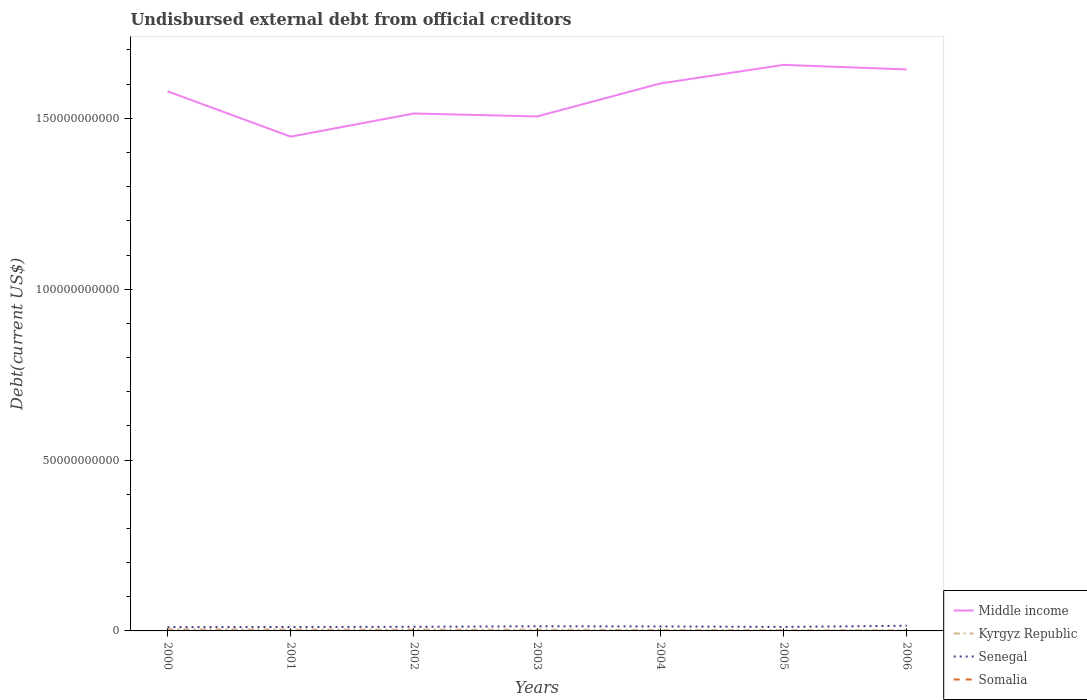Does the line corresponding to Middle income intersect with the line corresponding to Somalia?
Your answer should be very brief. No. Is the number of lines equal to the number of legend labels?
Offer a terse response. Yes. Across all years, what is the maximum total debt in Kyrgyz Republic?
Provide a succinct answer. 1.80e+08. In which year was the total debt in Kyrgyz Republic maximum?
Your answer should be compact. 2006. What is the total total debt in Middle income in the graph?
Your answer should be compact. -1.29e+1. What is the difference between the highest and the second highest total debt in Somalia?
Offer a terse response. 7.91e+06. What is the difference between the highest and the lowest total debt in Kyrgyz Republic?
Ensure brevity in your answer.  4. How many years are there in the graph?
Your answer should be compact. 7. Does the graph contain any zero values?
Keep it short and to the point. No. Does the graph contain grids?
Provide a short and direct response. No. What is the title of the graph?
Give a very brief answer. Undisbursed external debt from official creditors. What is the label or title of the Y-axis?
Give a very brief answer. Debt(current US$). What is the Debt(current US$) of Middle income in 2000?
Your answer should be very brief. 1.58e+11. What is the Debt(current US$) of Kyrgyz Republic in 2000?
Keep it short and to the point. 4.70e+08. What is the Debt(current US$) in Senegal in 2000?
Your answer should be very brief. 1.11e+09. What is the Debt(current US$) of Somalia in 2000?
Offer a terse response. 1.23e+07. What is the Debt(current US$) of Middle income in 2001?
Offer a terse response. 1.45e+11. What is the Debt(current US$) in Kyrgyz Republic in 2001?
Make the answer very short. 4.04e+08. What is the Debt(current US$) of Senegal in 2001?
Ensure brevity in your answer.  1.15e+09. What is the Debt(current US$) of Somalia in 2001?
Offer a very short reply. 1.23e+07. What is the Debt(current US$) of Middle income in 2002?
Make the answer very short. 1.51e+11. What is the Debt(current US$) of Kyrgyz Republic in 2002?
Give a very brief answer. 3.86e+08. What is the Debt(current US$) in Senegal in 2002?
Offer a terse response. 1.21e+09. What is the Debt(current US$) of Somalia in 2002?
Your response must be concise. 1.24e+07. What is the Debt(current US$) in Middle income in 2003?
Give a very brief answer. 1.51e+11. What is the Debt(current US$) in Kyrgyz Republic in 2003?
Make the answer very short. 3.73e+08. What is the Debt(current US$) of Senegal in 2003?
Your answer should be compact. 1.36e+09. What is the Debt(current US$) of Somalia in 2003?
Provide a succinct answer. 4.52e+06. What is the Debt(current US$) of Middle income in 2004?
Offer a very short reply. 1.60e+11. What is the Debt(current US$) in Kyrgyz Republic in 2004?
Offer a terse response. 2.79e+08. What is the Debt(current US$) in Senegal in 2004?
Give a very brief answer. 1.31e+09. What is the Debt(current US$) in Somalia in 2004?
Keep it short and to the point. 4.54e+06. What is the Debt(current US$) of Middle income in 2005?
Ensure brevity in your answer.  1.66e+11. What is the Debt(current US$) of Kyrgyz Republic in 2005?
Keep it short and to the point. 2.44e+08. What is the Debt(current US$) in Senegal in 2005?
Provide a short and direct response. 1.17e+09. What is the Debt(current US$) in Somalia in 2005?
Your answer should be very brief. 4.54e+06. What is the Debt(current US$) of Middle income in 2006?
Provide a short and direct response. 1.64e+11. What is the Debt(current US$) in Kyrgyz Republic in 2006?
Ensure brevity in your answer.  1.80e+08. What is the Debt(current US$) in Senegal in 2006?
Make the answer very short. 1.51e+09. What is the Debt(current US$) of Somalia in 2006?
Give a very brief answer. 4.60e+06. Across all years, what is the maximum Debt(current US$) of Middle income?
Provide a short and direct response. 1.66e+11. Across all years, what is the maximum Debt(current US$) in Kyrgyz Republic?
Your answer should be very brief. 4.70e+08. Across all years, what is the maximum Debt(current US$) in Senegal?
Ensure brevity in your answer.  1.51e+09. Across all years, what is the maximum Debt(current US$) of Somalia?
Provide a short and direct response. 1.24e+07. Across all years, what is the minimum Debt(current US$) of Middle income?
Make the answer very short. 1.45e+11. Across all years, what is the minimum Debt(current US$) of Kyrgyz Republic?
Your response must be concise. 1.80e+08. Across all years, what is the minimum Debt(current US$) of Senegal?
Provide a short and direct response. 1.11e+09. Across all years, what is the minimum Debt(current US$) in Somalia?
Your answer should be very brief. 4.52e+06. What is the total Debt(current US$) in Middle income in the graph?
Provide a short and direct response. 1.09e+12. What is the total Debt(current US$) of Kyrgyz Republic in the graph?
Give a very brief answer. 2.34e+09. What is the total Debt(current US$) in Senegal in the graph?
Offer a very short reply. 8.82e+09. What is the total Debt(current US$) in Somalia in the graph?
Offer a terse response. 5.52e+07. What is the difference between the Debt(current US$) of Middle income in 2000 and that in 2001?
Provide a succinct answer. 1.33e+1. What is the difference between the Debt(current US$) in Kyrgyz Republic in 2000 and that in 2001?
Offer a very short reply. 6.66e+07. What is the difference between the Debt(current US$) of Senegal in 2000 and that in 2001?
Ensure brevity in your answer.  -4.41e+07. What is the difference between the Debt(current US$) of Somalia in 2000 and that in 2001?
Your answer should be compact. 4.60e+04. What is the difference between the Debt(current US$) of Middle income in 2000 and that in 2002?
Your answer should be compact. 6.49e+09. What is the difference between the Debt(current US$) of Kyrgyz Republic in 2000 and that in 2002?
Give a very brief answer. 8.46e+07. What is the difference between the Debt(current US$) of Senegal in 2000 and that in 2002?
Keep it short and to the point. -1.01e+08. What is the difference between the Debt(current US$) of Somalia in 2000 and that in 2002?
Provide a short and direct response. -9.10e+04. What is the difference between the Debt(current US$) of Middle income in 2000 and that in 2003?
Give a very brief answer. 7.36e+09. What is the difference between the Debt(current US$) of Kyrgyz Republic in 2000 and that in 2003?
Provide a short and direct response. 9.78e+07. What is the difference between the Debt(current US$) in Senegal in 2000 and that in 2003?
Give a very brief answer. -2.56e+08. What is the difference between the Debt(current US$) in Somalia in 2000 and that in 2003?
Your answer should be very brief. 7.82e+06. What is the difference between the Debt(current US$) in Middle income in 2000 and that in 2004?
Keep it short and to the point. -2.29e+09. What is the difference between the Debt(current US$) in Kyrgyz Republic in 2000 and that in 2004?
Offer a terse response. 1.91e+08. What is the difference between the Debt(current US$) in Senegal in 2000 and that in 2004?
Offer a very short reply. -2.04e+08. What is the difference between the Debt(current US$) of Somalia in 2000 and that in 2004?
Offer a terse response. 7.79e+06. What is the difference between the Debt(current US$) of Middle income in 2000 and that in 2005?
Provide a succinct answer. -7.73e+09. What is the difference between the Debt(current US$) of Kyrgyz Republic in 2000 and that in 2005?
Provide a succinct answer. 2.26e+08. What is the difference between the Debt(current US$) of Senegal in 2000 and that in 2005?
Keep it short and to the point. -6.37e+07. What is the difference between the Debt(current US$) of Somalia in 2000 and that in 2005?
Provide a short and direct response. 7.79e+06. What is the difference between the Debt(current US$) of Middle income in 2000 and that in 2006?
Provide a short and direct response. -6.40e+09. What is the difference between the Debt(current US$) in Kyrgyz Republic in 2000 and that in 2006?
Offer a very short reply. 2.90e+08. What is the difference between the Debt(current US$) of Senegal in 2000 and that in 2006?
Your answer should be very brief. -4.04e+08. What is the difference between the Debt(current US$) of Somalia in 2000 and that in 2006?
Offer a terse response. 7.73e+06. What is the difference between the Debt(current US$) of Middle income in 2001 and that in 2002?
Your answer should be compact. -6.78e+09. What is the difference between the Debt(current US$) in Kyrgyz Republic in 2001 and that in 2002?
Offer a terse response. 1.80e+07. What is the difference between the Debt(current US$) in Senegal in 2001 and that in 2002?
Keep it short and to the point. -5.67e+07. What is the difference between the Debt(current US$) in Somalia in 2001 and that in 2002?
Give a very brief answer. -1.37e+05. What is the difference between the Debt(current US$) of Middle income in 2001 and that in 2003?
Provide a succinct answer. -5.91e+09. What is the difference between the Debt(current US$) in Kyrgyz Republic in 2001 and that in 2003?
Provide a short and direct response. 3.12e+07. What is the difference between the Debt(current US$) of Senegal in 2001 and that in 2003?
Provide a succinct answer. -2.11e+08. What is the difference between the Debt(current US$) of Somalia in 2001 and that in 2003?
Give a very brief answer. 7.77e+06. What is the difference between the Debt(current US$) in Middle income in 2001 and that in 2004?
Provide a short and direct response. -1.56e+1. What is the difference between the Debt(current US$) of Kyrgyz Republic in 2001 and that in 2004?
Make the answer very short. 1.25e+08. What is the difference between the Debt(current US$) of Senegal in 2001 and that in 2004?
Your answer should be very brief. -1.60e+08. What is the difference between the Debt(current US$) in Somalia in 2001 and that in 2004?
Provide a short and direct response. 7.75e+06. What is the difference between the Debt(current US$) in Middle income in 2001 and that in 2005?
Your answer should be very brief. -2.10e+1. What is the difference between the Debt(current US$) in Kyrgyz Republic in 2001 and that in 2005?
Make the answer very short. 1.60e+08. What is the difference between the Debt(current US$) of Senegal in 2001 and that in 2005?
Give a very brief answer. -1.96e+07. What is the difference between the Debt(current US$) in Somalia in 2001 and that in 2005?
Make the answer very short. 7.74e+06. What is the difference between the Debt(current US$) in Middle income in 2001 and that in 2006?
Your response must be concise. -1.97e+1. What is the difference between the Debt(current US$) of Kyrgyz Republic in 2001 and that in 2006?
Keep it short and to the point. 2.24e+08. What is the difference between the Debt(current US$) in Senegal in 2001 and that in 2006?
Give a very brief answer. -3.60e+08. What is the difference between the Debt(current US$) of Somalia in 2001 and that in 2006?
Offer a very short reply. 7.68e+06. What is the difference between the Debt(current US$) of Middle income in 2002 and that in 2003?
Provide a short and direct response. 8.66e+08. What is the difference between the Debt(current US$) in Kyrgyz Republic in 2002 and that in 2003?
Offer a very short reply. 1.32e+07. What is the difference between the Debt(current US$) in Senegal in 2002 and that in 2003?
Your answer should be very brief. -1.55e+08. What is the difference between the Debt(current US$) in Somalia in 2002 and that in 2003?
Your answer should be compact. 7.91e+06. What is the difference between the Debt(current US$) in Middle income in 2002 and that in 2004?
Make the answer very short. -8.78e+09. What is the difference between the Debt(current US$) of Kyrgyz Republic in 2002 and that in 2004?
Offer a terse response. 1.07e+08. What is the difference between the Debt(current US$) in Senegal in 2002 and that in 2004?
Provide a short and direct response. -1.03e+08. What is the difference between the Debt(current US$) of Somalia in 2002 and that in 2004?
Provide a succinct answer. 7.88e+06. What is the difference between the Debt(current US$) in Middle income in 2002 and that in 2005?
Provide a short and direct response. -1.42e+1. What is the difference between the Debt(current US$) in Kyrgyz Republic in 2002 and that in 2005?
Offer a terse response. 1.42e+08. What is the difference between the Debt(current US$) of Senegal in 2002 and that in 2005?
Your response must be concise. 3.71e+07. What is the difference between the Debt(current US$) of Somalia in 2002 and that in 2005?
Ensure brevity in your answer.  7.88e+06. What is the difference between the Debt(current US$) of Middle income in 2002 and that in 2006?
Offer a very short reply. -1.29e+1. What is the difference between the Debt(current US$) of Kyrgyz Republic in 2002 and that in 2006?
Ensure brevity in your answer.  2.06e+08. What is the difference between the Debt(current US$) of Senegal in 2002 and that in 2006?
Give a very brief answer. -3.03e+08. What is the difference between the Debt(current US$) of Somalia in 2002 and that in 2006?
Your answer should be compact. 7.82e+06. What is the difference between the Debt(current US$) in Middle income in 2003 and that in 2004?
Keep it short and to the point. -9.64e+09. What is the difference between the Debt(current US$) in Kyrgyz Republic in 2003 and that in 2004?
Ensure brevity in your answer.  9.35e+07. What is the difference between the Debt(current US$) in Senegal in 2003 and that in 2004?
Keep it short and to the point. 5.16e+07. What is the difference between the Debt(current US$) in Somalia in 2003 and that in 2004?
Your answer should be compact. -2.10e+04. What is the difference between the Debt(current US$) of Middle income in 2003 and that in 2005?
Keep it short and to the point. -1.51e+1. What is the difference between the Debt(current US$) in Kyrgyz Republic in 2003 and that in 2005?
Your answer should be compact. 1.28e+08. What is the difference between the Debt(current US$) in Senegal in 2003 and that in 2005?
Make the answer very short. 1.92e+08. What is the difference between the Debt(current US$) in Somalia in 2003 and that in 2005?
Provide a succinct answer. -2.40e+04. What is the difference between the Debt(current US$) of Middle income in 2003 and that in 2006?
Keep it short and to the point. -1.38e+1. What is the difference between the Debt(current US$) of Kyrgyz Republic in 2003 and that in 2006?
Your answer should be very brief. 1.93e+08. What is the difference between the Debt(current US$) in Senegal in 2003 and that in 2006?
Offer a very short reply. -1.49e+08. What is the difference between the Debt(current US$) in Somalia in 2003 and that in 2006?
Your answer should be very brief. -8.50e+04. What is the difference between the Debt(current US$) in Middle income in 2004 and that in 2005?
Give a very brief answer. -5.45e+09. What is the difference between the Debt(current US$) in Kyrgyz Republic in 2004 and that in 2005?
Make the answer very short. 3.48e+07. What is the difference between the Debt(current US$) in Senegal in 2004 and that in 2005?
Give a very brief answer. 1.40e+08. What is the difference between the Debt(current US$) in Somalia in 2004 and that in 2005?
Your response must be concise. -3000. What is the difference between the Debt(current US$) in Middle income in 2004 and that in 2006?
Provide a short and direct response. -4.11e+09. What is the difference between the Debt(current US$) in Kyrgyz Republic in 2004 and that in 2006?
Your response must be concise. 9.90e+07. What is the difference between the Debt(current US$) of Senegal in 2004 and that in 2006?
Offer a very short reply. -2.00e+08. What is the difference between the Debt(current US$) of Somalia in 2004 and that in 2006?
Offer a very short reply. -6.40e+04. What is the difference between the Debt(current US$) of Middle income in 2005 and that in 2006?
Your answer should be very brief. 1.33e+09. What is the difference between the Debt(current US$) of Kyrgyz Republic in 2005 and that in 2006?
Offer a terse response. 6.42e+07. What is the difference between the Debt(current US$) of Senegal in 2005 and that in 2006?
Your response must be concise. -3.40e+08. What is the difference between the Debt(current US$) of Somalia in 2005 and that in 2006?
Ensure brevity in your answer.  -6.10e+04. What is the difference between the Debt(current US$) in Middle income in 2000 and the Debt(current US$) in Kyrgyz Republic in 2001?
Offer a terse response. 1.58e+11. What is the difference between the Debt(current US$) of Middle income in 2000 and the Debt(current US$) of Senegal in 2001?
Provide a short and direct response. 1.57e+11. What is the difference between the Debt(current US$) in Middle income in 2000 and the Debt(current US$) in Somalia in 2001?
Provide a succinct answer. 1.58e+11. What is the difference between the Debt(current US$) of Kyrgyz Republic in 2000 and the Debt(current US$) of Senegal in 2001?
Offer a very short reply. -6.81e+08. What is the difference between the Debt(current US$) in Kyrgyz Republic in 2000 and the Debt(current US$) in Somalia in 2001?
Offer a terse response. 4.58e+08. What is the difference between the Debt(current US$) in Senegal in 2000 and the Debt(current US$) in Somalia in 2001?
Make the answer very short. 1.09e+09. What is the difference between the Debt(current US$) of Middle income in 2000 and the Debt(current US$) of Kyrgyz Republic in 2002?
Provide a succinct answer. 1.58e+11. What is the difference between the Debt(current US$) in Middle income in 2000 and the Debt(current US$) in Senegal in 2002?
Make the answer very short. 1.57e+11. What is the difference between the Debt(current US$) in Middle income in 2000 and the Debt(current US$) in Somalia in 2002?
Offer a terse response. 1.58e+11. What is the difference between the Debt(current US$) of Kyrgyz Republic in 2000 and the Debt(current US$) of Senegal in 2002?
Offer a very short reply. -7.37e+08. What is the difference between the Debt(current US$) of Kyrgyz Republic in 2000 and the Debt(current US$) of Somalia in 2002?
Provide a short and direct response. 4.58e+08. What is the difference between the Debt(current US$) in Senegal in 2000 and the Debt(current US$) in Somalia in 2002?
Keep it short and to the point. 1.09e+09. What is the difference between the Debt(current US$) in Middle income in 2000 and the Debt(current US$) in Kyrgyz Republic in 2003?
Provide a short and direct response. 1.58e+11. What is the difference between the Debt(current US$) of Middle income in 2000 and the Debt(current US$) of Senegal in 2003?
Your response must be concise. 1.57e+11. What is the difference between the Debt(current US$) of Middle income in 2000 and the Debt(current US$) of Somalia in 2003?
Ensure brevity in your answer.  1.58e+11. What is the difference between the Debt(current US$) in Kyrgyz Republic in 2000 and the Debt(current US$) in Senegal in 2003?
Offer a very short reply. -8.92e+08. What is the difference between the Debt(current US$) of Kyrgyz Republic in 2000 and the Debt(current US$) of Somalia in 2003?
Keep it short and to the point. 4.66e+08. What is the difference between the Debt(current US$) of Senegal in 2000 and the Debt(current US$) of Somalia in 2003?
Your answer should be compact. 1.10e+09. What is the difference between the Debt(current US$) of Middle income in 2000 and the Debt(current US$) of Kyrgyz Republic in 2004?
Provide a short and direct response. 1.58e+11. What is the difference between the Debt(current US$) in Middle income in 2000 and the Debt(current US$) in Senegal in 2004?
Offer a terse response. 1.57e+11. What is the difference between the Debt(current US$) in Middle income in 2000 and the Debt(current US$) in Somalia in 2004?
Provide a short and direct response. 1.58e+11. What is the difference between the Debt(current US$) in Kyrgyz Republic in 2000 and the Debt(current US$) in Senegal in 2004?
Give a very brief answer. -8.41e+08. What is the difference between the Debt(current US$) of Kyrgyz Republic in 2000 and the Debt(current US$) of Somalia in 2004?
Provide a succinct answer. 4.66e+08. What is the difference between the Debt(current US$) of Senegal in 2000 and the Debt(current US$) of Somalia in 2004?
Make the answer very short. 1.10e+09. What is the difference between the Debt(current US$) in Middle income in 2000 and the Debt(current US$) in Kyrgyz Republic in 2005?
Your response must be concise. 1.58e+11. What is the difference between the Debt(current US$) of Middle income in 2000 and the Debt(current US$) of Senegal in 2005?
Provide a short and direct response. 1.57e+11. What is the difference between the Debt(current US$) in Middle income in 2000 and the Debt(current US$) in Somalia in 2005?
Your response must be concise. 1.58e+11. What is the difference between the Debt(current US$) in Kyrgyz Republic in 2000 and the Debt(current US$) in Senegal in 2005?
Provide a short and direct response. -7.00e+08. What is the difference between the Debt(current US$) in Kyrgyz Republic in 2000 and the Debt(current US$) in Somalia in 2005?
Make the answer very short. 4.66e+08. What is the difference between the Debt(current US$) in Senegal in 2000 and the Debt(current US$) in Somalia in 2005?
Make the answer very short. 1.10e+09. What is the difference between the Debt(current US$) in Middle income in 2000 and the Debt(current US$) in Kyrgyz Republic in 2006?
Keep it short and to the point. 1.58e+11. What is the difference between the Debt(current US$) in Middle income in 2000 and the Debt(current US$) in Senegal in 2006?
Your answer should be compact. 1.56e+11. What is the difference between the Debt(current US$) of Middle income in 2000 and the Debt(current US$) of Somalia in 2006?
Your answer should be very brief. 1.58e+11. What is the difference between the Debt(current US$) in Kyrgyz Republic in 2000 and the Debt(current US$) in Senegal in 2006?
Keep it short and to the point. -1.04e+09. What is the difference between the Debt(current US$) in Kyrgyz Republic in 2000 and the Debt(current US$) in Somalia in 2006?
Your answer should be very brief. 4.66e+08. What is the difference between the Debt(current US$) of Senegal in 2000 and the Debt(current US$) of Somalia in 2006?
Your answer should be compact. 1.10e+09. What is the difference between the Debt(current US$) of Middle income in 2001 and the Debt(current US$) of Kyrgyz Republic in 2002?
Ensure brevity in your answer.  1.44e+11. What is the difference between the Debt(current US$) of Middle income in 2001 and the Debt(current US$) of Senegal in 2002?
Offer a terse response. 1.43e+11. What is the difference between the Debt(current US$) in Middle income in 2001 and the Debt(current US$) in Somalia in 2002?
Your response must be concise. 1.45e+11. What is the difference between the Debt(current US$) in Kyrgyz Republic in 2001 and the Debt(current US$) in Senegal in 2002?
Your answer should be compact. -8.04e+08. What is the difference between the Debt(current US$) of Kyrgyz Republic in 2001 and the Debt(current US$) of Somalia in 2002?
Your answer should be compact. 3.91e+08. What is the difference between the Debt(current US$) in Senegal in 2001 and the Debt(current US$) in Somalia in 2002?
Ensure brevity in your answer.  1.14e+09. What is the difference between the Debt(current US$) of Middle income in 2001 and the Debt(current US$) of Kyrgyz Republic in 2003?
Provide a succinct answer. 1.44e+11. What is the difference between the Debt(current US$) in Middle income in 2001 and the Debt(current US$) in Senegal in 2003?
Ensure brevity in your answer.  1.43e+11. What is the difference between the Debt(current US$) of Middle income in 2001 and the Debt(current US$) of Somalia in 2003?
Keep it short and to the point. 1.45e+11. What is the difference between the Debt(current US$) of Kyrgyz Republic in 2001 and the Debt(current US$) of Senegal in 2003?
Give a very brief answer. -9.59e+08. What is the difference between the Debt(current US$) of Kyrgyz Republic in 2001 and the Debt(current US$) of Somalia in 2003?
Your response must be concise. 3.99e+08. What is the difference between the Debt(current US$) of Senegal in 2001 and the Debt(current US$) of Somalia in 2003?
Keep it short and to the point. 1.15e+09. What is the difference between the Debt(current US$) in Middle income in 2001 and the Debt(current US$) in Kyrgyz Republic in 2004?
Provide a short and direct response. 1.44e+11. What is the difference between the Debt(current US$) in Middle income in 2001 and the Debt(current US$) in Senegal in 2004?
Provide a short and direct response. 1.43e+11. What is the difference between the Debt(current US$) in Middle income in 2001 and the Debt(current US$) in Somalia in 2004?
Make the answer very short. 1.45e+11. What is the difference between the Debt(current US$) in Kyrgyz Republic in 2001 and the Debt(current US$) in Senegal in 2004?
Keep it short and to the point. -9.07e+08. What is the difference between the Debt(current US$) of Kyrgyz Republic in 2001 and the Debt(current US$) of Somalia in 2004?
Give a very brief answer. 3.99e+08. What is the difference between the Debt(current US$) in Senegal in 2001 and the Debt(current US$) in Somalia in 2004?
Offer a very short reply. 1.15e+09. What is the difference between the Debt(current US$) of Middle income in 2001 and the Debt(current US$) of Kyrgyz Republic in 2005?
Your answer should be very brief. 1.44e+11. What is the difference between the Debt(current US$) in Middle income in 2001 and the Debt(current US$) in Senegal in 2005?
Your answer should be very brief. 1.43e+11. What is the difference between the Debt(current US$) in Middle income in 2001 and the Debt(current US$) in Somalia in 2005?
Your response must be concise. 1.45e+11. What is the difference between the Debt(current US$) in Kyrgyz Republic in 2001 and the Debt(current US$) in Senegal in 2005?
Keep it short and to the point. -7.67e+08. What is the difference between the Debt(current US$) of Kyrgyz Republic in 2001 and the Debt(current US$) of Somalia in 2005?
Make the answer very short. 3.99e+08. What is the difference between the Debt(current US$) in Senegal in 2001 and the Debt(current US$) in Somalia in 2005?
Provide a short and direct response. 1.15e+09. What is the difference between the Debt(current US$) of Middle income in 2001 and the Debt(current US$) of Kyrgyz Republic in 2006?
Keep it short and to the point. 1.44e+11. What is the difference between the Debt(current US$) in Middle income in 2001 and the Debt(current US$) in Senegal in 2006?
Your answer should be compact. 1.43e+11. What is the difference between the Debt(current US$) of Middle income in 2001 and the Debt(current US$) of Somalia in 2006?
Give a very brief answer. 1.45e+11. What is the difference between the Debt(current US$) of Kyrgyz Republic in 2001 and the Debt(current US$) of Senegal in 2006?
Your answer should be very brief. -1.11e+09. What is the difference between the Debt(current US$) in Kyrgyz Republic in 2001 and the Debt(current US$) in Somalia in 2006?
Your answer should be compact. 3.99e+08. What is the difference between the Debt(current US$) of Senegal in 2001 and the Debt(current US$) of Somalia in 2006?
Make the answer very short. 1.15e+09. What is the difference between the Debt(current US$) in Middle income in 2002 and the Debt(current US$) in Kyrgyz Republic in 2003?
Offer a very short reply. 1.51e+11. What is the difference between the Debt(current US$) in Middle income in 2002 and the Debt(current US$) in Senegal in 2003?
Provide a short and direct response. 1.50e+11. What is the difference between the Debt(current US$) of Middle income in 2002 and the Debt(current US$) of Somalia in 2003?
Offer a terse response. 1.51e+11. What is the difference between the Debt(current US$) in Kyrgyz Republic in 2002 and the Debt(current US$) in Senegal in 2003?
Keep it short and to the point. -9.77e+08. What is the difference between the Debt(current US$) of Kyrgyz Republic in 2002 and the Debt(current US$) of Somalia in 2003?
Your answer should be very brief. 3.81e+08. What is the difference between the Debt(current US$) in Senegal in 2002 and the Debt(current US$) in Somalia in 2003?
Offer a terse response. 1.20e+09. What is the difference between the Debt(current US$) of Middle income in 2002 and the Debt(current US$) of Kyrgyz Republic in 2004?
Ensure brevity in your answer.  1.51e+11. What is the difference between the Debt(current US$) of Middle income in 2002 and the Debt(current US$) of Senegal in 2004?
Your answer should be compact. 1.50e+11. What is the difference between the Debt(current US$) in Middle income in 2002 and the Debt(current US$) in Somalia in 2004?
Give a very brief answer. 1.51e+11. What is the difference between the Debt(current US$) of Kyrgyz Republic in 2002 and the Debt(current US$) of Senegal in 2004?
Offer a very short reply. -9.25e+08. What is the difference between the Debt(current US$) of Kyrgyz Republic in 2002 and the Debt(current US$) of Somalia in 2004?
Make the answer very short. 3.81e+08. What is the difference between the Debt(current US$) in Senegal in 2002 and the Debt(current US$) in Somalia in 2004?
Ensure brevity in your answer.  1.20e+09. What is the difference between the Debt(current US$) in Middle income in 2002 and the Debt(current US$) in Kyrgyz Republic in 2005?
Ensure brevity in your answer.  1.51e+11. What is the difference between the Debt(current US$) in Middle income in 2002 and the Debt(current US$) in Senegal in 2005?
Keep it short and to the point. 1.50e+11. What is the difference between the Debt(current US$) of Middle income in 2002 and the Debt(current US$) of Somalia in 2005?
Your answer should be very brief. 1.51e+11. What is the difference between the Debt(current US$) in Kyrgyz Republic in 2002 and the Debt(current US$) in Senegal in 2005?
Your response must be concise. -7.85e+08. What is the difference between the Debt(current US$) of Kyrgyz Republic in 2002 and the Debt(current US$) of Somalia in 2005?
Ensure brevity in your answer.  3.81e+08. What is the difference between the Debt(current US$) of Senegal in 2002 and the Debt(current US$) of Somalia in 2005?
Provide a short and direct response. 1.20e+09. What is the difference between the Debt(current US$) in Middle income in 2002 and the Debt(current US$) in Kyrgyz Republic in 2006?
Offer a terse response. 1.51e+11. What is the difference between the Debt(current US$) in Middle income in 2002 and the Debt(current US$) in Senegal in 2006?
Your answer should be compact. 1.50e+11. What is the difference between the Debt(current US$) of Middle income in 2002 and the Debt(current US$) of Somalia in 2006?
Your response must be concise. 1.51e+11. What is the difference between the Debt(current US$) in Kyrgyz Republic in 2002 and the Debt(current US$) in Senegal in 2006?
Keep it short and to the point. -1.13e+09. What is the difference between the Debt(current US$) of Kyrgyz Republic in 2002 and the Debt(current US$) of Somalia in 2006?
Ensure brevity in your answer.  3.81e+08. What is the difference between the Debt(current US$) in Senegal in 2002 and the Debt(current US$) in Somalia in 2006?
Your answer should be very brief. 1.20e+09. What is the difference between the Debt(current US$) in Middle income in 2003 and the Debt(current US$) in Kyrgyz Republic in 2004?
Offer a very short reply. 1.50e+11. What is the difference between the Debt(current US$) in Middle income in 2003 and the Debt(current US$) in Senegal in 2004?
Your answer should be compact. 1.49e+11. What is the difference between the Debt(current US$) in Middle income in 2003 and the Debt(current US$) in Somalia in 2004?
Provide a short and direct response. 1.51e+11. What is the difference between the Debt(current US$) of Kyrgyz Republic in 2003 and the Debt(current US$) of Senegal in 2004?
Provide a succinct answer. -9.38e+08. What is the difference between the Debt(current US$) of Kyrgyz Republic in 2003 and the Debt(current US$) of Somalia in 2004?
Your answer should be very brief. 3.68e+08. What is the difference between the Debt(current US$) of Senegal in 2003 and the Debt(current US$) of Somalia in 2004?
Your response must be concise. 1.36e+09. What is the difference between the Debt(current US$) in Middle income in 2003 and the Debt(current US$) in Kyrgyz Republic in 2005?
Your answer should be compact. 1.50e+11. What is the difference between the Debt(current US$) in Middle income in 2003 and the Debt(current US$) in Senegal in 2005?
Provide a succinct answer. 1.49e+11. What is the difference between the Debt(current US$) of Middle income in 2003 and the Debt(current US$) of Somalia in 2005?
Give a very brief answer. 1.51e+11. What is the difference between the Debt(current US$) in Kyrgyz Republic in 2003 and the Debt(current US$) in Senegal in 2005?
Give a very brief answer. -7.98e+08. What is the difference between the Debt(current US$) in Kyrgyz Republic in 2003 and the Debt(current US$) in Somalia in 2005?
Your response must be concise. 3.68e+08. What is the difference between the Debt(current US$) of Senegal in 2003 and the Debt(current US$) of Somalia in 2005?
Offer a very short reply. 1.36e+09. What is the difference between the Debt(current US$) in Middle income in 2003 and the Debt(current US$) in Kyrgyz Republic in 2006?
Ensure brevity in your answer.  1.50e+11. What is the difference between the Debt(current US$) of Middle income in 2003 and the Debt(current US$) of Senegal in 2006?
Ensure brevity in your answer.  1.49e+11. What is the difference between the Debt(current US$) in Middle income in 2003 and the Debt(current US$) in Somalia in 2006?
Offer a very short reply. 1.51e+11. What is the difference between the Debt(current US$) in Kyrgyz Republic in 2003 and the Debt(current US$) in Senegal in 2006?
Provide a short and direct response. -1.14e+09. What is the difference between the Debt(current US$) in Kyrgyz Republic in 2003 and the Debt(current US$) in Somalia in 2006?
Offer a very short reply. 3.68e+08. What is the difference between the Debt(current US$) in Senegal in 2003 and the Debt(current US$) in Somalia in 2006?
Your response must be concise. 1.36e+09. What is the difference between the Debt(current US$) in Middle income in 2004 and the Debt(current US$) in Kyrgyz Republic in 2005?
Keep it short and to the point. 1.60e+11. What is the difference between the Debt(current US$) in Middle income in 2004 and the Debt(current US$) in Senegal in 2005?
Keep it short and to the point. 1.59e+11. What is the difference between the Debt(current US$) of Middle income in 2004 and the Debt(current US$) of Somalia in 2005?
Your answer should be compact. 1.60e+11. What is the difference between the Debt(current US$) in Kyrgyz Republic in 2004 and the Debt(current US$) in Senegal in 2005?
Provide a succinct answer. -8.92e+08. What is the difference between the Debt(current US$) in Kyrgyz Republic in 2004 and the Debt(current US$) in Somalia in 2005?
Your answer should be very brief. 2.75e+08. What is the difference between the Debt(current US$) in Senegal in 2004 and the Debt(current US$) in Somalia in 2005?
Give a very brief answer. 1.31e+09. What is the difference between the Debt(current US$) in Middle income in 2004 and the Debt(current US$) in Kyrgyz Republic in 2006?
Provide a succinct answer. 1.60e+11. What is the difference between the Debt(current US$) of Middle income in 2004 and the Debt(current US$) of Senegal in 2006?
Your answer should be very brief. 1.59e+11. What is the difference between the Debt(current US$) in Middle income in 2004 and the Debt(current US$) in Somalia in 2006?
Your response must be concise. 1.60e+11. What is the difference between the Debt(current US$) of Kyrgyz Republic in 2004 and the Debt(current US$) of Senegal in 2006?
Give a very brief answer. -1.23e+09. What is the difference between the Debt(current US$) of Kyrgyz Republic in 2004 and the Debt(current US$) of Somalia in 2006?
Offer a very short reply. 2.75e+08. What is the difference between the Debt(current US$) of Senegal in 2004 and the Debt(current US$) of Somalia in 2006?
Offer a terse response. 1.31e+09. What is the difference between the Debt(current US$) of Middle income in 2005 and the Debt(current US$) of Kyrgyz Republic in 2006?
Your answer should be very brief. 1.65e+11. What is the difference between the Debt(current US$) in Middle income in 2005 and the Debt(current US$) in Senegal in 2006?
Your answer should be compact. 1.64e+11. What is the difference between the Debt(current US$) of Middle income in 2005 and the Debt(current US$) of Somalia in 2006?
Offer a very short reply. 1.66e+11. What is the difference between the Debt(current US$) in Kyrgyz Republic in 2005 and the Debt(current US$) in Senegal in 2006?
Provide a succinct answer. -1.27e+09. What is the difference between the Debt(current US$) in Kyrgyz Republic in 2005 and the Debt(current US$) in Somalia in 2006?
Your answer should be compact. 2.40e+08. What is the difference between the Debt(current US$) in Senegal in 2005 and the Debt(current US$) in Somalia in 2006?
Keep it short and to the point. 1.17e+09. What is the average Debt(current US$) in Middle income per year?
Keep it short and to the point. 1.56e+11. What is the average Debt(current US$) in Kyrgyz Republic per year?
Keep it short and to the point. 3.34e+08. What is the average Debt(current US$) of Senegal per year?
Your response must be concise. 1.26e+09. What is the average Debt(current US$) of Somalia per year?
Provide a succinct answer. 7.89e+06. In the year 2000, what is the difference between the Debt(current US$) in Middle income and Debt(current US$) in Kyrgyz Republic?
Offer a terse response. 1.57e+11. In the year 2000, what is the difference between the Debt(current US$) in Middle income and Debt(current US$) in Senegal?
Keep it short and to the point. 1.57e+11. In the year 2000, what is the difference between the Debt(current US$) of Middle income and Debt(current US$) of Somalia?
Ensure brevity in your answer.  1.58e+11. In the year 2000, what is the difference between the Debt(current US$) of Kyrgyz Republic and Debt(current US$) of Senegal?
Give a very brief answer. -6.37e+08. In the year 2000, what is the difference between the Debt(current US$) in Kyrgyz Republic and Debt(current US$) in Somalia?
Your response must be concise. 4.58e+08. In the year 2000, what is the difference between the Debt(current US$) in Senegal and Debt(current US$) in Somalia?
Provide a short and direct response. 1.09e+09. In the year 2001, what is the difference between the Debt(current US$) in Middle income and Debt(current US$) in Kyrgyz Republic?
Your response must be concise. 1.44e+11. In the year 2001, what is the difference between the Debt(current US$) in Middle income and Debt(current US$) in Senegal?
Keep it short and to the point. 1.43e+11. In the year 2001, what is the difference between the Debt(current US$) in Middle income and Debt(current US$) in Somalia?
Offer a terse response. 1.45e+11. In the year 2001, what is the difference between the Debt(current US$) of Kyrgyz Republic and Debt(current US$) of Senegal?
Offer a terse response. -7.47e+08. In the year 2001, what is the difference between the Debt(current US$) in Kyrgyz Republic and Debt(current US$) in Somalia?
Provide a short and direct response. 3.92e+08. In the year 2001, what is the difference between the Debt(current US$) of Senegal and Debt(current US$) of Somalia?
Give a very brief answer. 1.14e+09. In the year 2002, what is the difference between the Debt(current US$) of Middle income and Debt(current US$) of Kyrgyz Republic?
Give a very brief answer. 1.51e+11. In the year 2002, what is the difference between the Debt(current US$) in Middle income and Debt(current US$) in Senegal?
Keep it short and to the point. 1.50e+11. In the year 2002, what is the difference between the Debt(current US$) of Middle income and Debt(current US$) of Somalia?
Provide a succinct answer. 1.51e+11. In the year 2002, what is the difference between the Debt(current US$) of Kyrgyz Republic and Debt(current US$) of Senegal?
Offer a very short reply. -8.22e+08. In the year 2002, what is the difference between the Debt(current US$) in Kyrgyz Republic and Debt(current US$) in Somalia?
Provide a short and direct response. 3.74e+08. In the year 2002, what is the difference between the Debt(current US$) of Senegal and Debt(current US$) of Somalia?
Offer a terse response. 1.20e+09. In the year 2003, what is the difference between the Debt(current US$) of Middle income and Debt(current US$) of Kyrgyz Republic?
Your answer should be very brief. 1.50e+11. In the year 2003, what is the difference between the Debt(current US$) in Middle income and Debt(current US$) in Senegal?
Make the answer very short. 1.49e+11. In the year 2003, what is the difference between the Debt(current US$) in Middle income and Debt(current US$) in Somalia?
Offer a very short reply. 1.51e+11. In the year 2003, what is the difference between the Debt(current US$) of Kyrgyz Republic and Debt(current US$) of Senegal?
Offer a very short reply. -9.90e+08. In the year 2003, what is the difference between the Debt(current US$) of Kyrgyz Republic and Debt(current US$) of Somalia?
Offer a very short reply. 3.68e+08. In the year 2003, what is the difference between the Debt(current US$) of Senegal and Debt(current US$) of Somalia?
Offer a terse response. 1.36e+09. In the year 2004, what is the difference between the Debt(current US$) in Middle income and Debt(current US$) in Kyrgyz Republic?
Give a very brief answer. 1.60e+11. In the year 2004, what is the difference between the Debt(current US$) in Middle income and Debt(current US$) in Senegal?
Your response must be concise. 1.59e+11. In the year 2004, what is the difference between the Debt(current US$) of Middle income and Debt(current US$) of Somalia?
Your answer should be compact. 1.60e+11. In the year 2004, what is the difference between the Debt(current US$) in Kyrgyz Republic and Debt(current US$) in Senegal?
Give a very brief answer. -1.03e+09. In the year 2004, what is the difference between the Debt(current US$) of Kyrgyz Republic and Debt(current US$) of Somalia?
Provide a succinct answer. 2.75e+08. In the year 2004, what is the difference between the Debt(current US$) of Senegal and Debt(current US$) of Somalia?
Ensure brevity in your answer.  1.31e+09. In the year 2005, what is the difference between the Debt(current US$) of Middle income and Debt(current US$) of Kyrgyz Republic?
Your response must be concise. 1.65e+11. In the year 2005, what is the difference between the Debt(current US$) of Middle income and Debt(current US$) of Senegal?
Make the answer very short. 1.64e+11. In the year 2005, what is the difference between the Debt(current US$) in Middle income and Debt(current US$) in Somalia?
Make the answer very short. 1.66e+11. In the year 2005, what is the difference between the Debt(current US$) in Kyrgyz Republic and Debt(current US$) in Senegal?
Provide a succinct answer. -9.26e+08. In the year 2005, what is the difference between the Debt(current US$) of Kyrgyz Republic and Debt(current US$) of Somalia?
Your answer should be compact. 2.40e+08. In the year 2005, what is the difference between the Debt(current US$) in Senegal and Debt(current US$) in Somalia?
Offer a very short reply. 1.17e+09. In the year 2006, what is the difference between the Debt(current US$) in Middle income and Debt(current US$) in Kyrgyz Republic?
Your response must be concise. 1.64e+11. In the year 2006, what is the difference between the Debt(current US$) in Middle income and Debt(current US$) in Senegal?
Offer a terse response. 1.63e+11. In the year 2006, what is the difference between the Debt(current US$) of Middle income and Debt(current US$) of Somalia?
Provide a succinct answer. 1.64e+11. In the year 2006, what is the difference between the Debt(current US$) of Kyrgyz Republic and Debt(current US$) of Senegal?
Provide a succinct answer. -1.33e+09. In the year 2006, what is the difference between the Debt(current US$) in Kyrgyz Republic and Debt(current US$) in Somalia?
Ensure brevity in your answer.  1.76e+08. In the year 2006, what is the difference between the Debt(current US$) of Senegal and Debt(current US$) of Somalia?
Offer a very short reply. 1.51e+09. What is the ratio of the Debt(current US$) in Middle income in 2000 to that in 2001?
Your answer should be compact. 1.09. What is the ratio of the Debt(current US$) in Kyrgyz Republic in 2000 to that in 2001?
Ensure brevity in your answer.  1.16. What is the ratio of the Debt(current US$) in Senegal in 2000 to that in 2001?
Make the answer very short. 0.96. What is the ratio of the Debt(current US$) of Somalia in 2000 to that in 2001?
Provide a short and direct response. 1. What is the ratio of the Debt(current US$) of Middle income in 2000 to that in 2002?
Offer a very short reply. 1.04. What is the ratio of the Debt(current US$) in Kyrgyz Republic in 2000 to that in 2002?
Keep it short and to the point. 1.22. What is the ratio of the Debt(current US$) in Senegal in 2000 to that in 2002?
Give a very brief answer. 0.92. What is the ratio of the Debt(current US$) in Somalia in 2000 to that in 2002?
Offer a terse response. 0.99. What is the ratio of the Debt(current US$) in Middle income in 2000 to that in 2003?
Keep it short and to the point. 1.05. What is the ratio of the Debt(current US$) in Kyrgyz Republic in 2000 to that in 2003?
Keep it short and to the point. 1.26. What is the ratio of the Debt(current US$) in Senegal in 2000 to that in 2003?
Ensure brevity in your answer.  0.81. What is the ratio of the Debt(current US$) in Somalia in 2000 to that in 2003?
Offer a terse response. 2.73. What is the ratio of the Debt(current US$) of Middle income in 2000 to that in 2004?
Offer a very short reply. 0.99. What is the ratio of the Debt(current US$) of Kyrgyz Republic in 2000 to that in 2004?
Provide a succinct answer. 1.69. What is the ratio of the Debt(current US$) in Senegal in 2000 to that in 2004?
Your response must be concise. 0.84. What is the ratio of the Debt(current US$) in Somalia in 2000 to that in 2004?
Your answer should be very brief. 2.72. What is the ratio of the Debt(current US$) of Middle income in 2000 to that in 2005?
Give a very brief answer. 0.95. What is the ratio of the Debt(current US$) of Kyrgyz Republic in 2000 to that in 2005?
Ensure brevity in your answer.  1.93. What is the ratio of the Debt(current US$) in Senegal in 2000 to that in 2005?
Give a very brief answer. 0.95. What is the ratio of the Debt(current US$) in Somalia in 2000 to that in 2005?
Offer a very short reply. 2.72. What is the ratio of the Debt(current US$) of Middle income in 2000 to that in 2006?
Keep it short and to the point. 0.96. What is the ratio of the Debt(current US$) in Kyrgyz Republic in 2000 to that in 2006?
Provide a short and direct response. 2.61. What is the ratio of the Debt(current US$) in Senegal in 2000 to that in 2006?
Give a very brief answer. 0.73. What is the ratio of the Debt(current US$) in Somalia in 2000 to that in 2006?
Keep it short and to the point. 2.68. What is the ratio of the Debt(current US$) in Middle income in 2001 to that in 2002?
Keep it short and to the point. 0.96. What is the ratio of the Debt(current US$) of Kyrgyz Republic in 2001 to that in 2002?
Offer a terse response. 1.05. What is the ratio of the Debt(current US$) in Senegal in 2001 to that in 2002?
Your answer should be very brief. 0.95. What is the ratio of the Debt(current US$) in Somalia in 2001 to that in 2002?
Ensure brevity in your answer.  0.99. What is the ratio of the Debt(current US$) of Middle income in 2001 to that in 2003?
Ensure brevity in your answer.  0.96. What is the ratio of the Debt(current US$) of Kyrgyz Republic in 2001 to that in 2003?
Provide a short and direct response. 1.08. What is the ratio of the Debt(current US$) of Senegal in 2001 to that in 2003?
Your answer should be very brief. 0.84. What is the ratio of the Debt(current US$) in Somalia in 2001 to that in 2003?
Your answer should be very brief. 2.72. What is the ratio of the Debt(current US$) in Middle income in 2001 to that in 2004?
Offer a very short reply. 0.9. What is the ratio of the Debt(current US$) of Kyrgyz Republic in 2001 to that in 2004?
Make the answer very short. 1.45. What is the ratio of the Debt(current US$) in Senegal in 2001 to that in 2004?
Your answer should be very brief. 0.88. What is the ratio of the Debt(current US$) of Somalia in 2001 to that in 2004?
Give a very brief answer. 2.71. What is the ratio of the Debt(current US$) of Middle income in 2001 to that in 2005?
Ensure brevity in your answer.  0.87. What is the ratio of the Debt(current US$) of Kyrgyz Republic in 2001 to that in 2005?
Offer a very short reply. 1.65. What is the ratio of the Debt(current US$) of Senegal in 2001 to that in 2005?
Your answer should be very brief. 0.98. What is the ratio of the Debt(current US$) of Somalia in 2001 to that in 2005?
Offer a very short reply. 2.71. What is the ratio of the Debt(current US$) in Middle income in 2001 to that in 2006?
Offer a very short reply. 0.88. What is the ratio of the Debt(current US$) in Kyrgyz Republic in 2001 to that in 2006?
Your answer should be very brief. 2.24. What is the ratio of the Debt(current US$) of Senegal in 2001 to that in 2006?
Keep it short and to the point. 0.76. What is the ratio of the Debt(current US$) of Somalia in 2001 to that in 2006?
Your answer should be compact. 2.67. What is the ratio of the Debt(current US$) of Kyrgyz Republic in 2002 to that in 2003?
Offer a very short reply. 1.04. What is the ratio of the Debt(current US$) of Senegal in 2002 to that in 2003?
Your answer should be compact. 0.89. What is the ratio of the Debt(current US$) in Somalia in 2002 to that in 2003?
Your answer should be very brief. 2.75. What is the ratio of the Debt(current US$) in Middle income in 2002 to that in 2004?
Your answer should be compact. 0.95. What is the ratio of the Debt(current US$) in Kyrgyz Republic in 2002 to that in 2004?
Keep it short and to the point. 1.38. What is the ratio of the Debt(current US$) in Senegal in 2002 to that in 2004?
Your response must be concise. 0.92. What is the ratio of the Debt(current US$) in Somalia in 2002 to that in 2004?
Provide a short and direct response. 2.74. What is the ratio of the Debt(current US$) in Middle income in 2002 to that in 2005?
Provide a succinct answer. 0.91. What is the ratio of the Debt(current US$) of Kyrgyz Republic in 2002 to that in 2005?
Ensure brevity in your answer.  1.58. What is the ratio of the Debt(current US$) in Senegal in 2002 to that in 2005?
Ensure brevity in your answer.  1.03. What is the ratio of the Debt(current US$) in Somalia in 2002 to that in 2005?
Offer a very short reply. 2.74. What is the ratio of the Debt(current US$) of Middle income in 2002 to that in 2006?
Ensure brevity in your answer.  0.92. What is the ratio of the Debt(current US$) of Kyrgyz Republic in 2002 to that in 2006?
Make the answer very short. 2.14. What is the ratio of the Debt(current US$) of Senegal in 2002 to that in 2006?
Your answer should be very brief. 0.8. What is the ratio of the Debt(current US$) of Somalia in 2002 to that in 2006?
Your response must be concise. 2.7. What is the ratio of the Debt(current US$) of Middle income in 2003 to that in 2004?
Provide a succinct answer. 0.94. What is the ratio of the Debt(current US$) in Kyrgyz Republic in 2003 to that in 2004?
Provide a short and direct response. 1.33. What is the ratio of the Debt(current US$) of Senegal in 2003 to that in 2004?
Give a very brief answer. 1.04. What is the ratio of the Debt(current US$) in Somalia in 2003 to that in 2004?
Provide a short and direct response. 1. What is the ratio of the Debt(current US$) of Middle income in 2003 to that in 2005?
Ensure brevity in your answer.  0.91. What is the ratio of the Debt(current US$) in Kyrgyz Republic in 2003 to that in 2005?
Offer a very short reply. 1.53. What is the ratio of the Debt(current US$) in Senegal in 2003 to that in 2005?
Ensure brevity in your answer.  1.16. What is the ratio of the Debt(current US$) of Somalia in 2003 to that in 2005?
Offer a terse response. 0.99. What is the ratio of the Debt(current US$) of Middle income in 2003 to that in 2006?
Provide a succinct answer. 0.92. What is the ratio of the Debt(current US$) in Kyrgyz Republic in 2003 to that in 2006?
Your answer should be very brief. 2.07. What is the ratio of the Debt(current US$) of Senegal in 2003 to that in 2006?
Your response must be concise. 0.9. What is the ratio of the Debt(current US$) in Somalia in 2003 to that in 2006?
Provide a succinct answer. 0.98. What is the ratio of the Debt(current US$) in Middle income in 2004 to that in 2005?
Offer a terse response. 0.97. What is the ratio of the Debt(current US$) of Kyrgyz Republic in 2004 to that in 2005?
Offer a terse response. 1.14. What is the ratio of the Debt(current US$) in Senegal in 2004 to that in 2005?
Keep it short and to the point. 1.12. What is the ratio of the Debt(current US$) of Somalia in 2004 to that in 2005?
Keep it short and to the point. 1. What is the ratio of the Debt(current US$) in Middle income in 2004 to that in 2006?
Give a very brief answer. 0.97. What is the ratio of the Debt(current US$) in Kyrgyz Republic in 2004 to that in 2006?
Offer a terse response. 1.55. What is the ratio of the Debt(current US$) of Senegal in 2004 to that in 2006?
Your answer should be compact. 0.87. What is the ratio of the Debt(current US$) in Somalia in 2004 to that in 2006?
Keep it short and to the point. 0.99. What is the ratio of the Debt(current US$) of Middle income in 2005 to that in 2006?
Provide a succinct answer. 1.01. What is the ratio of the Debt(current US$) of Kyrgyz Republic in 2005 to that in 2006?
Keep it short and to the point. 1.36. What is the ratio of the Debt(current US$) in Senegal in 2005 to that in 2006?
Ensure brevity in your answer.  0.77. What is the ratio of the Debt(current US$) in Somalia in 2005 to that in 2006?
Provide a short and direct response. 0.99. What is the difference between the highest and the second highest Debt(current US$) of Middle income?
Provide a succinct answer. 1.33e+09. What is the difference between the highest and the second highest Debt(current US$) in Kyrgyz Republic?
Make the answer very short. 6.66e+07. What is the difference between the highest and the second highest Debt(current US$) of Senegal?
Your answer should be very brief. 1.49e+08. What is the difference between the highest and the second highest Debt(current US$) of Somalia?
Your answer should be very brief. 9.10e+04. What is the difference between the highest and the lowest Debt(current US$) in Middle income?
Your answer should be very brief. 2.10e+1. What is the difference between the highest and the lowest Debt(current US$) in Kyrgyz Republic?
Offer a very short reply. 2.90e+08. What is the difference between the highest and the lowest Debt(current US$) in Senegal?
Offer a very short reply. 4.04e+08. What is the difference between the highest and the lowest Debt(current US$) in Somalia?
Your answer should be compact. 7.91e+06. 